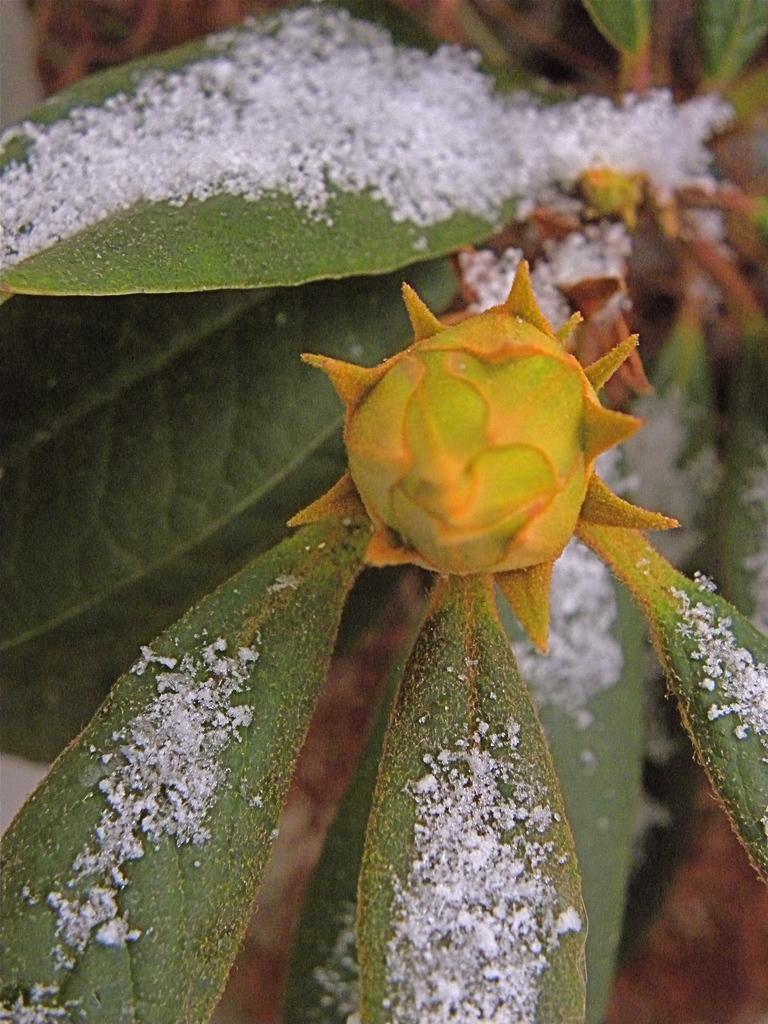Describe this image in one or two sentences. In this image we can see a plant with buds on it. 